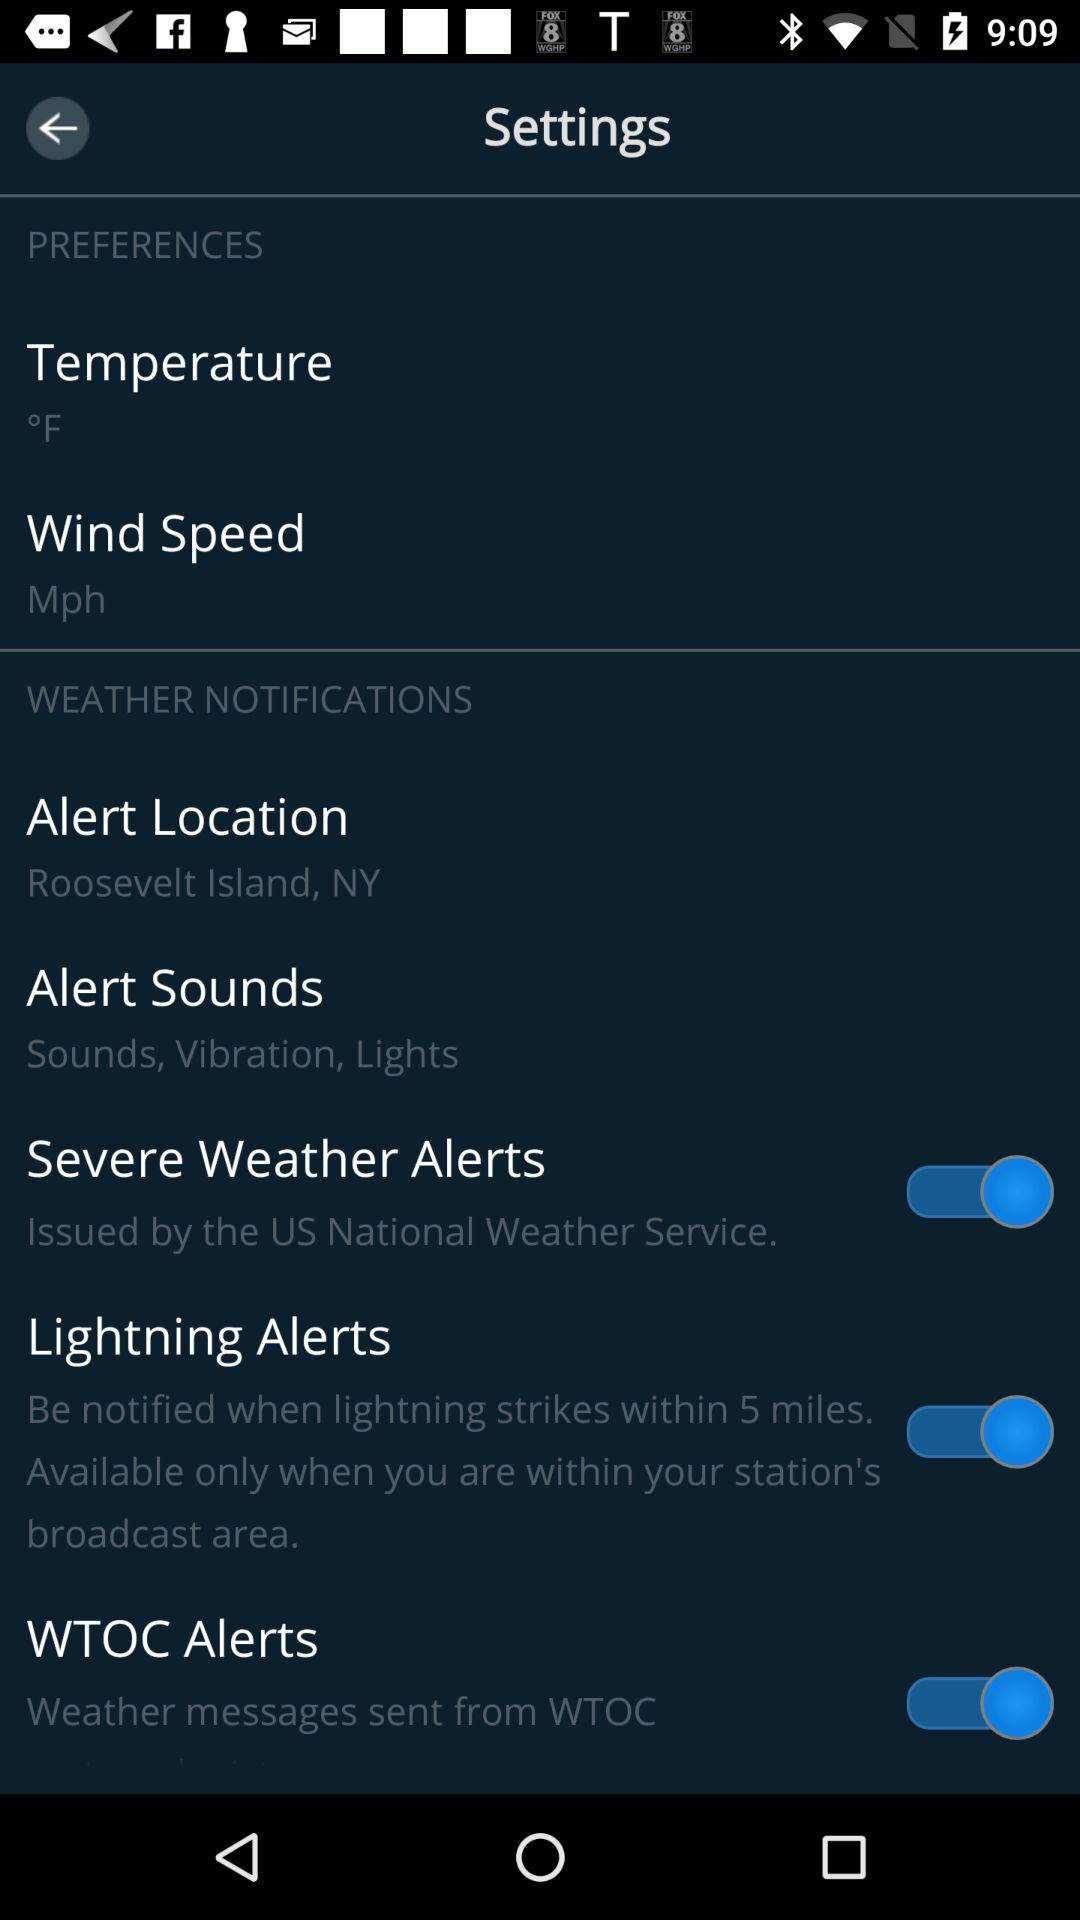How many items have a switch?
Answer the question using a single word or phrase. 3 